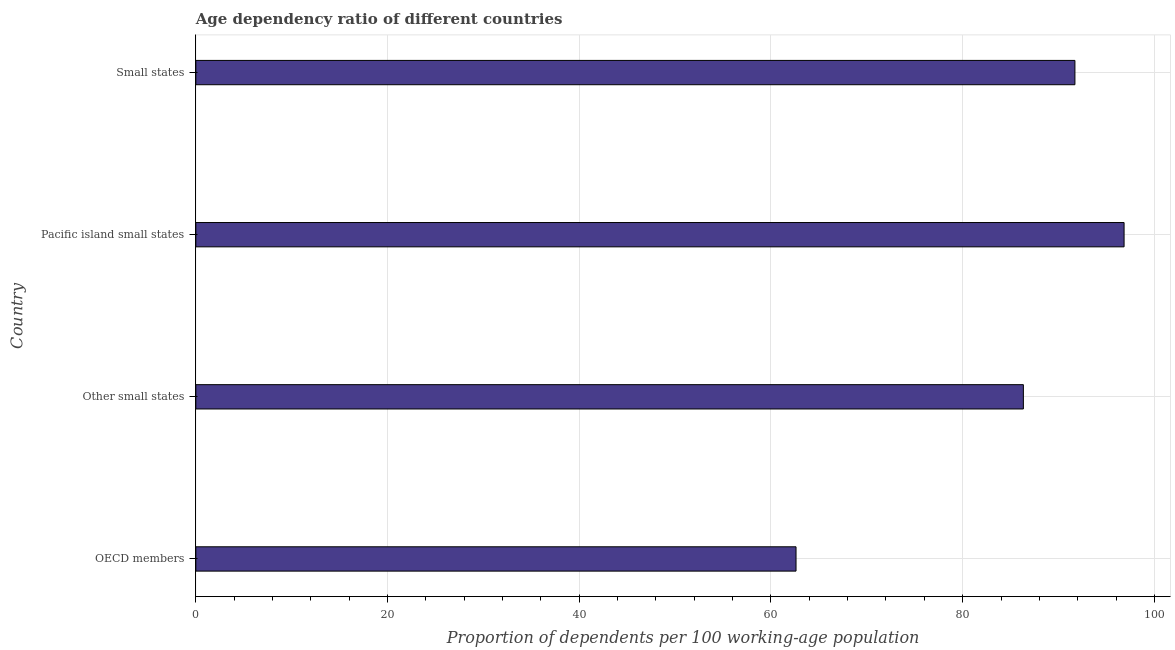What is the title of the graph?
Ensure brevity in your answer.  Age dependency ratio of different countries. What is the label or title of the X-axis?
Your answer should be very brief. Proportion of dependents per 100 working-age population. What is the label or title of the Y-axis?
Ensure brevity in your answer.  Country. What is the age dependency ratio in OECD members?
Ensure brevity in your answer.  62.61. Across all countries, what is the maximum age dependency ratio?
Your answer should be compact. 96.84. Across all countries, what is the minimum age dependency ratio?
Your answer should be very brief. 62.61. In which country was the age dependency ratio maximum?
Your answer should be compact. Pacific island small states. In which country was the age dependency ratio minimum?
Your answer should be very brief. OECD members. What is the sum of the age dependency ratio?
Offer a very short reply. 337.5. What is the difference between the age dependency ratio in Other small states and Small states?
Offer a terse response. -5.38. What is the average age dependency ratio per country?
Your answer should be very brief. 84.37. What is the median age dependency ratio?
Offer a very short reply. 89.02. In how many countries, is the age dependency ratio greater than 28 ?
Ensure brevity in your answer.  4. What is the ratio of the age dependency ratio in Pacific island small states to that in Small states?
Your answer should be very brief. 1.06. What is the difference between the highest and the second highest age dependency ratio?
Provide a succinct answer. 5.13. What is the difference between the highest and the lowest age dependency ratio?
Make the answer very short. 34.22. How many bars are there?
Your answer should be very brief. 4. How many countries are there in the graph?
Provide a short and direct response. 4. What is the difference between two consecutive major ticks on the X-axis?
Your response must be concise. 20. What is the Proportion of dependents per 100 working-age population in OECD members?
Your answer should be compact. 62.61. What is the Proportion of dependents per 100 working-age population of Other small states?
Give a very brief answer. 86.33. What is the Proportion of dependents per 100 working-age population of Pacific island small states?
Provide a succinct answer. 96.84. What is the Proportion of dependents per 100 working-age population of Small states?
Offer a terse response. 91.71. What is the difference between the Proportion of dependents per 100 working-age population in OECD members and Other small states?
Your response must be concise. -23.72. What is the difference between the Proportion of dependents per 100 working-age population in OECD members and Pacific island small states?
Make the answer very short. -34.22. What is the difference between the Proportion of dependents per 100 working-age population in OECD members and Small states?
Offer a very short reply. -29.1. What is the difference between the Proportion of dependents per 100 working-age population in Other small states and Pacific island small states?
Your answer should be very brief. -10.51. What is the difference between the Proportion of dependents per 100 working-age population in Other small states and Small states?
Offer a very short reply. -5.38. What is the difference between the Proportion of dependents per 100 working-age population in Pacific island small states and Small states?
Provide a short and direct response. 5.13. What is the ratio of the Proportion of dependents per 100 working-age population in OECD members to that in Other small states?
Your answer should be compact. 0.72. What is the ratio of the Proportion of dependents per 100 working-age population in OECD members to that in Pacific island small states?
Make the answer very short. 0.65. What is the ratio of the Proportion of dependents per 100 working-age population in OECD members to that in Small states?
Ensure brevity in your answer.  0.68. What is the ratio of the Proportion of dependents per 100 working-age population in Other small states to that in Pacific island small states?
Ensure brevity in your answer.  0.89. What is the ratio of the Proportion of dependents per 100 working-age population in Other small states to that in Small states?
Your answer should be compact. 0.94. What is the ratio of the Proportion of dependents per 100 working-age population in Pacific island small states to that in Small states?
Keep it short and to the point. 1.06. 